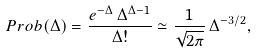Convert formula to latex. <formula><loc_0><loc_0><loc_500><loc_500>P r o b ( \Delta ) = \frac { e ^ { - \Delta } \, \Delta ^ { \Delta - 1 } } { \Delta ! } \simeq \frac { 1 } { \sqrt { 2 \pi } } \, \Delta ^ { - 3 / 2 } ,</formula> 